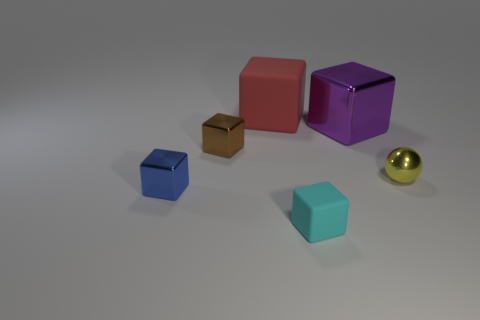Subtract all small rubber cubes. How many cubes are left? 4 Subtract all blue blocks. How many blocks are left? 4 Subtract all green blocks. Subtract all gray cylinders. How many blocks are left? 5 Add 3 tiny blue shiny cubes. How many objects exist? 9 Subtract all blocks. How many objects are left? 1 Subtract all big red blocks. Subtract all purple cubes. How many objects are left? 4 Add 1 yellow metal things. How many yellow metal things are left? 2 Add 4 big yellow blocks. How many big yellow blocks exist? 4 Subtract 1 yellow balls. How many objects are left? 5 